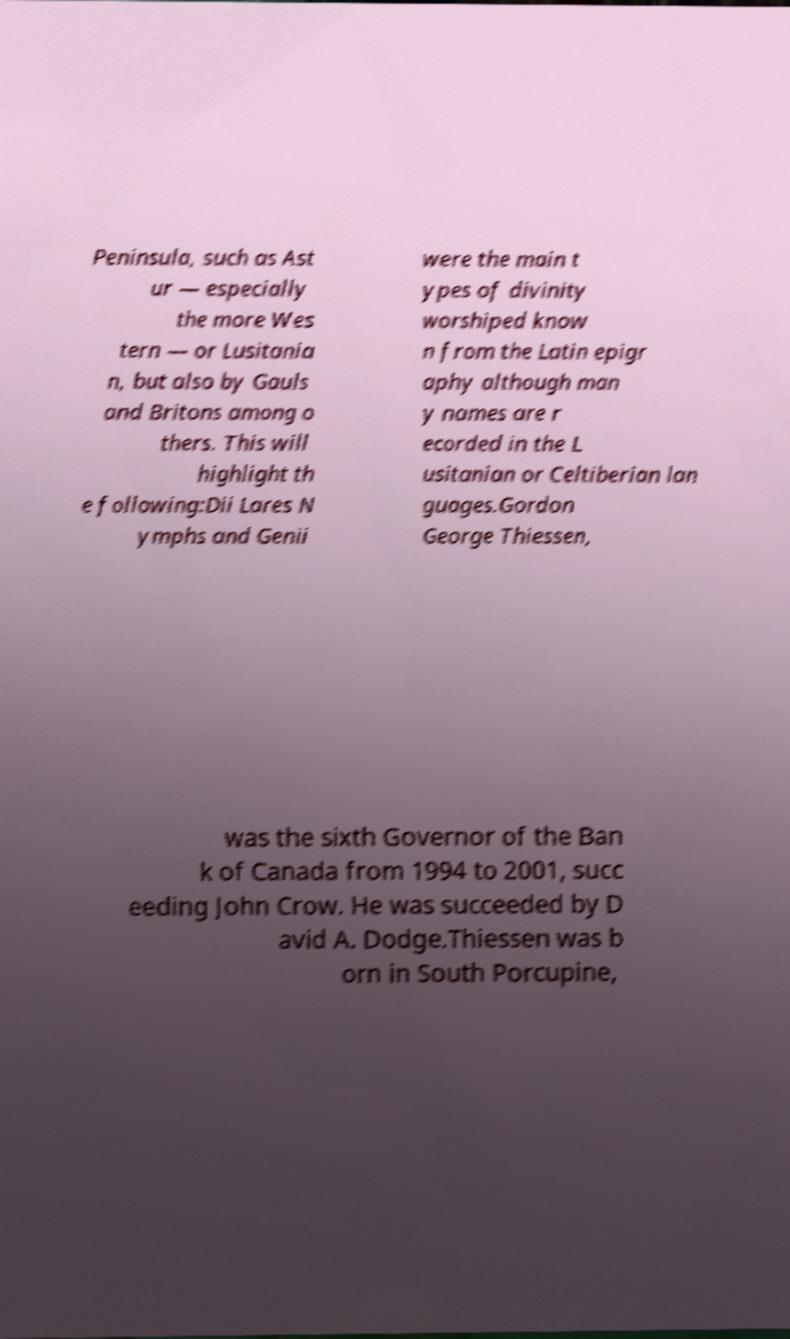Could you extract and type out the text from this image? Peninsula, such as Ast ur — especially the more Wes tern — or Lusitania n, but also by Gauls and Britons among o thers. This will highlight th e following:Dii Lares N ymphs and Genii were the main t ypes of divinity worshiped know n from the Latin epigr aphy although man y names are r ecorded in the L usitanian or Celtiberian lan guages.Gordon George Thiessen, was the sixth Governor of the Ban k of Canada from 1994 to 2001, succ eeding John Crow. He was succeeded by D avid A. Dodge.Thiessen was b orn in South Porcupine, 